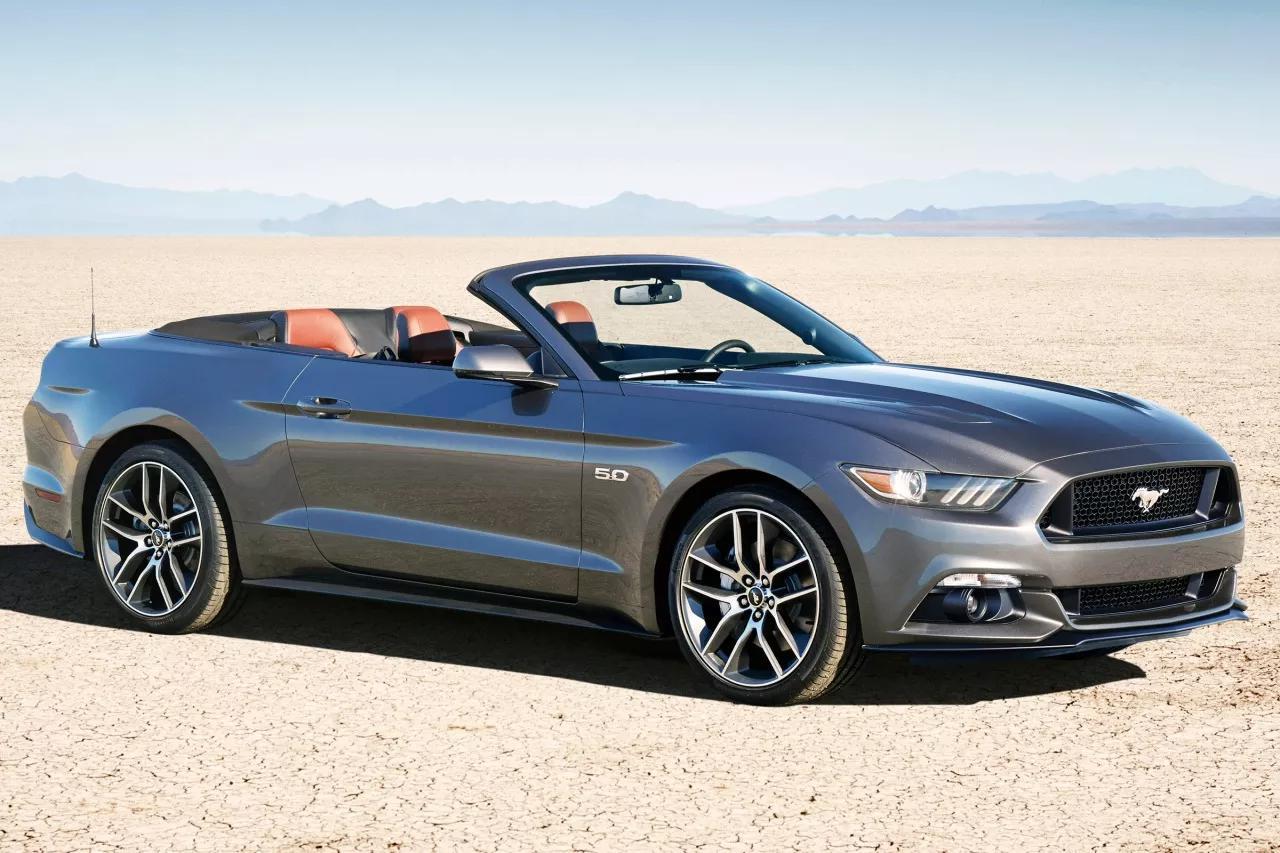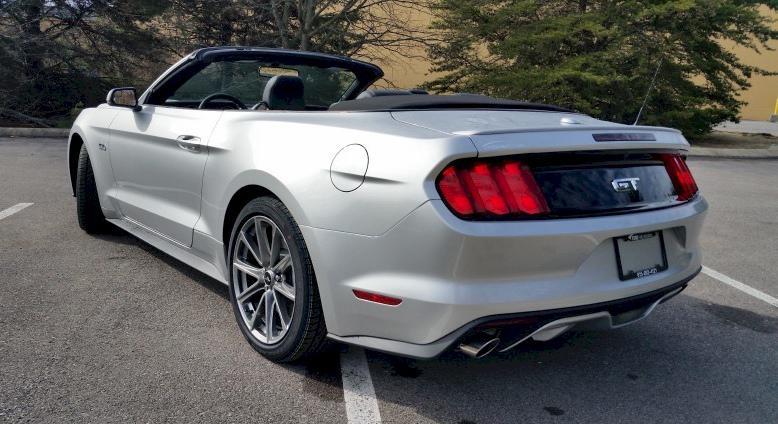The first image is the image on the left, the second image is the image on the right. For the images shown, is this caption "All cars are facing left." true? Answer yes or no. No. 